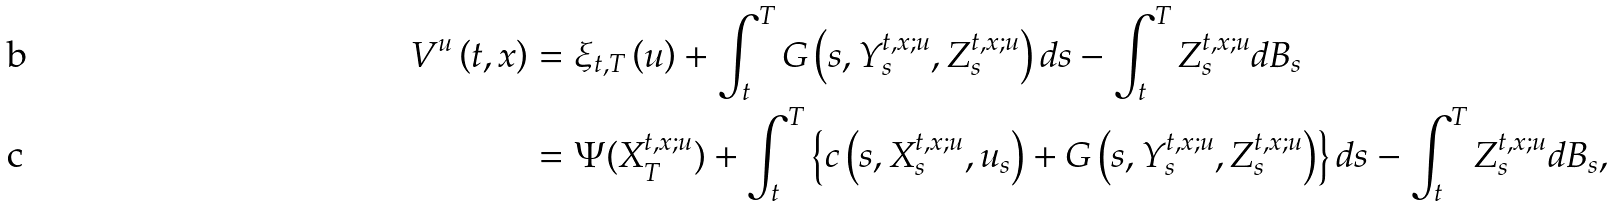Convert formula to latex. <formula><loc_0><loc_0><loc_500><loc_500>V ^ { u } \left ( t , x \right ) & = \xi _ { t , T } \left ( u \right ) + \int _ { t } ^ { T } G \left ( s , Y _ { s } ^ { t , x ; u } , Z _ { s } ^ { t , x ; u } \right ) d s - \int _ { t } ^ { T } Z _ { s } ^ { t , x ; u } d B _ { s } \\ & = \Psi ( X _ { T } ^ { t , x ; u } ) + \int _ { t } ^ { T } \left \{ c \left ( s , X _ { s } ^ { t , x ; u } , u _ { s } \right ) + G \left ( s , Y _ { s } ^ { t , x ; u } , Z _ { s } ^ { t , x ; u } \right ) \right \} d s - \int _ { t } ^ { T } Z _ { s } ^ { t , x ; u } d B _ { s } ,</formula> 